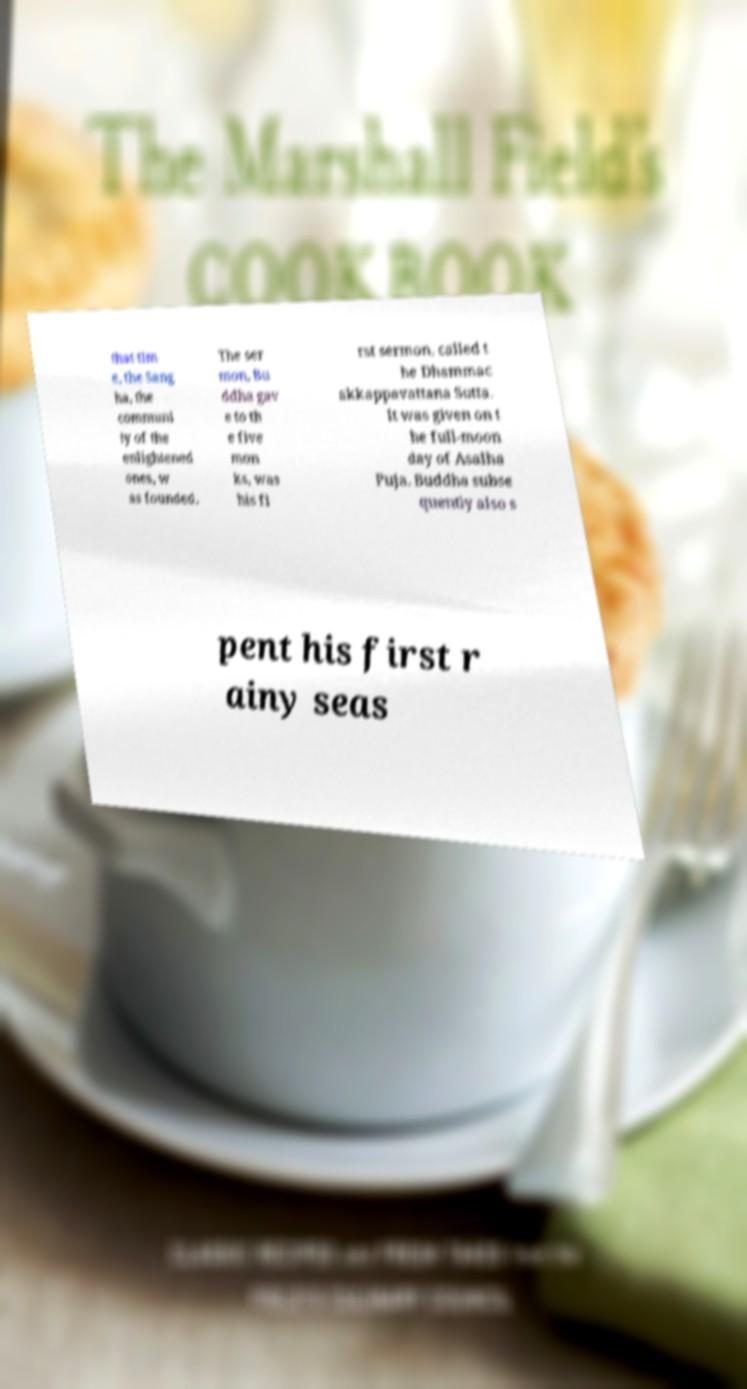Can you read and provide the text displayed in the image?This photo seems to have some interesting text. Can you extract and type it out for me? that tim e, the Sang ha, the communi ty of the enlightened ones, w as founded. The ser mon, Bu ddha gav e to th e five mon ks, was his fi rst sermon, called t he Dhammac akkappavattana Sutta. It was given on t he full-moon day of Asalha Puja. Buddha subse quently also s pent his first r ainy seas 